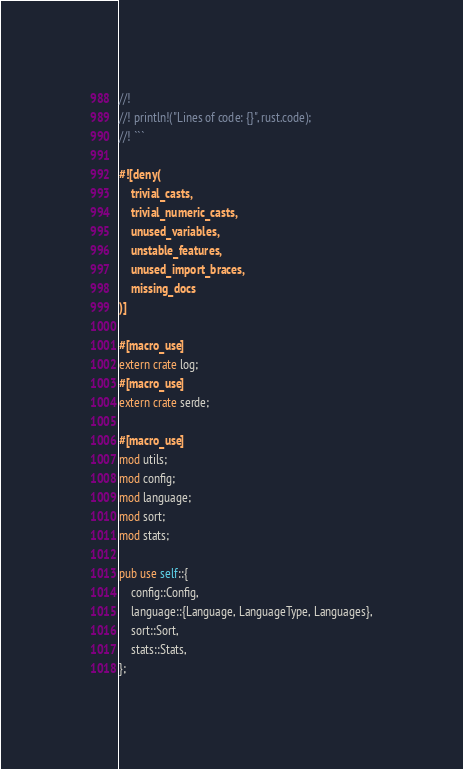Convert code to text. <code><loc_0><loc_0><loc_500><loc_500><_Rust_>//!
//! println!("Lines of code: {}", rust.code);
//! ```

#![deny(
    trivial_casts,
    trivial_numeric_casts,
    unused_variables,
    unstable_features,
    unused_import_braces,
    missing_docs
)]

#[macro_use]
extern crate log;
#[macro_use]
extern crate serde;

#[macro_use]
mod utils;
mod config;
mod language;
mod sort;
mod stats;

pub use self::{
    config::Config,
    language::{Language, LanguageType, Languages},
    sort::Sort,
    stats::Stats,
};
</code> 